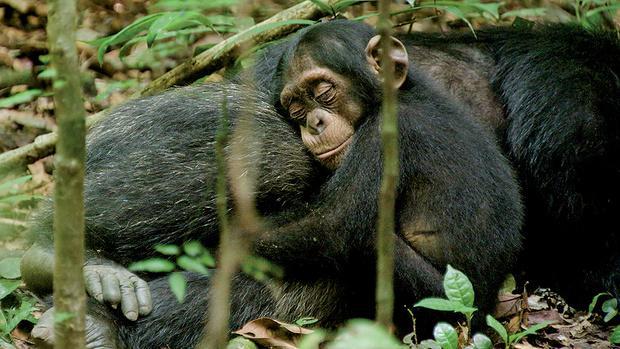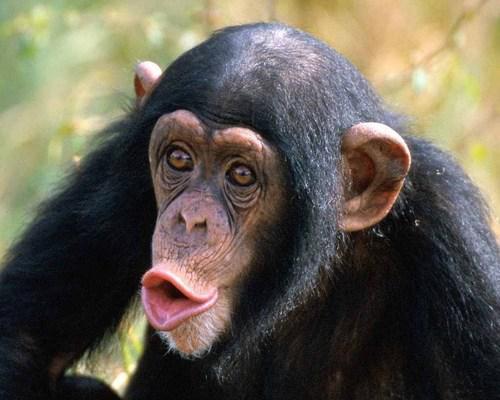The first image is the image on the left, the second image is the image on the right. Assess this claim about the two images: "There are two apes". Correct or not? Answer yes or no. No. The first image is the image on the left, the second image is the image on the right. Given the left and right images, does the statement "In the left image, one chimp is baring its teeth." hold true? Answer yes or no. No. 